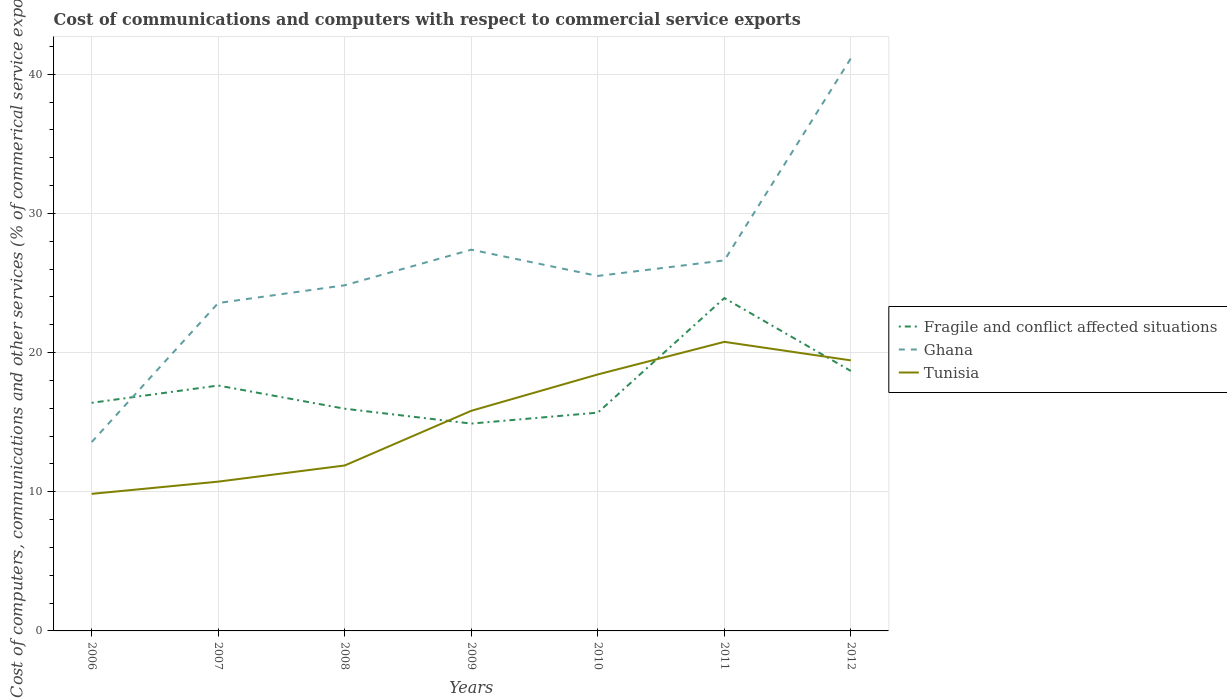Does the line corresponding to Ghana intersect with the line corresponding to Fragile and conflict affected situations?
Your response must be concise. Yes. Across all years, what is the maximum cost of communications and computers in Tunisia?
Your response must be concise. 9.85. What is the total cost of communications and computers in Ghana in the graph?
Provide a succinct answer. -13.75. What is the difference between the highest and the second highest cost of communications and computers in Ghana?
Ensure brevity in your answer.  27.57. How many lines are there?
Your response must be concise. 3. How many years are there in the graph?
Ensure brevity in your answer.  7. Are the values on the major ticks of Y-axis written in scientific E-notation?
Provide a succinct answer. No. Does the graph contain grids?
Give a very brief answer. Yes. Where does the legend appear in the graph?
Your response must be concise. Center right. How many legend labels are there?
Keep it short and to the point. 3. What is the title of the graph?
Offer a very short reply. Cost of communications and computers with respect to commercial service exports. Does "Hungary" appear as one of the legend labels in the graph?
Your answer should be compact. No. What is the label or title of the Y-axis?
Ensure brevity in your answer.  Cost of computers, communications and other services (% of commerical service exports). What is the Cost of computers, communications and other services (% of commerical service exports) in Fragile and conflict affected situations in 2006?
Make the answer very short. 16.39. What is the Cost of computers, communications and other services (% of commerical service exports) of Ghana in 2006?
Your answer should be very brief. 13.57. What is the Cost of computers, communications and other services (% of commerical service exports) in Tunisia in 2006?
Keep it short and to the point. 9.85. What is the Cost of computers, communications and other services (% of commerical service exports) of Fragile and conflict affected situations in 2007?
Make the answer very short. 17.63. What is the Cost of computers, communications and other services (% of commerical service exports) of Ghana in 2007?
Give a very brief answer. 23.56. What is the Cost of computers, communications and other services (% of commerical service exports) in Tunisia in 2007?
Ensure brevity in your answer.  10.73. What is the Cost of computers, communications and other services (% of commerical service exports) of Fragile and conflict affected situations in 2008?
Your answer should be very brief. 15.97. What is the Cost of computers, communications and other services (% of commerical service exports) in Ghana in 2008?
Provide a short and direct response. 24.84. What is the Cost of computers, communications and other services (% of commerical service exports) in Tunisia in 2008?
Your response must be concise. 11.89. What is the Cost of computers, communications and other services (% of commerical service exports) of Fragile and conflict affected situations in 2009?
Your response must be concise. 14.9. What is the Cost of computers, communications and other services (% of commerical service exports) in Ghana in 2009?
Keep it short and to the point. 27.39. What is the Cost of computers, communications and other services (% of commerical service exports) of Tunisia in 2009?
Make the answer very short. 15.82. What is the Cost of computers, communications and other services (% of commerical service exports) of Fragile and conflict affected situations in 2010?
Provide a succinct answer. 15.68. What is the Cost of computers, communications and other services (% of commerical service exports) in Ghana in 2010?
Keep it short and to the point. 25.51. What is the Cost of computers, communications and other services (% of commerical service exports) in Tunisia in 2010?
Provide a short and direct response. 18.43. What is the Cost of computers, communications and other services (% of commerical service exports) of Fragile and conflict affected situations in 2011?
Your response must be concise. 23.92. What is the Cost of computers, communications and other services (% of commerical service exports) in Ghana in 2011?
Keep it short and to the point. 26.62. What is the Cost of computers, communications and other services (% of commerical service exports) in Tunisia in 2011?
Your response must be concise. 20.77. What is the Cost of computers, communications and other services (% of commerical service exports) of Fragile and conflict affected situations in 2012?
Your answer should be compact. 18.68. What is the Cost of computers, communications and other services (% of commerical service exports) in Ghana in 2012?
Keep it short and to the point. 41.14. What is the Cost of computers, communications and other services (% of commerical service exports) of Tunisia in 2012?
Provide a succinct answer. 19.44. Across all years, what is the maximum Cost of computers, communications and other services (% of commerical service exports) in Fragile and conflict affected situations?
Provide a succinct answer. 23.92. Across all years, what is the maximum Cost of computers, communications and other services (% of commerical service exports) in Ghana?
Give a very brief answer. 41.14. Across all years, what is the maximum Cost of computers, communications and other services (% of commerical service exports) of Tunisia?
Provide a succinct answer. 20.77. Across all years, what is the minimum Cost of computers, communications and other services (% of commerical service exports) in Fragile and conflict affected situations?
Offer a very short reply. 14.9. Across all years, what is the minimum Cost of computers, communications and other services (% of commerical service exports) in Ghana?
Give a very brief answer. 13.57. Across all years, what is the minimum Cost of computers, communications and other services (% of commerical service exports) in Tunisia?
Offer a terse response. 9.85. What is the total Cost of computers, communications and other services (% of commerical service exports) in Fragile and conflict affected situations in the graph?
Make the answer very short. 123.17. What is the total Cost of computers, communications and other services (% of commerical service exports) of Ghana in the graph?
Ensure brevity in your answer.  182.63. What is the total Cost of computers, communications and other services (% of commerical service exports) of Tunisia in the graph?
Make the answer very short. 106.92. What is the difference between the Cost of computers, communications and other services (% of commerical service exports) in Fragile and conflict affected situations in 2006 and that in 2007?
Provide a short and direct response. -1.24. What is the difference between the Cost of computers, communications and other services (% of commerical service exports) of Ghana in 2006 and that in 2007?
Your answer should be compact. -9.99. What is the difference between the Cost of computers, communications and other services (% of commerical service exports) of Tunisia in 2006 and that in 2007?
Offer a terse response. -0.88. What is the difference between the Cost of computers, communications and other services (% of commerical service exports) of Fragile and conflict affected situations in 2006 and that in 2008?
Your answer should be compact. 0.42. What is the difference between the Cost of computers, communications and other services (% of commerical service exports) of Ghana in 2006 and that in 2008?
Give a very brief answer. -11.27. What is the difference between the Cost of computers, communications and other services (% of commerical service exports) in Tunisia in 2006 and that in 2008?
Offer a terse response. -2.04. What is the difference between the Cost of computers, communications and other services (% of commerical service exports) in Fragile and conflict affected situations in 2006 and that in 2009?
Give a very brief answer. 1.49. What is the difference between the Cost of computers, communications and other services (% of commerical service exports) in Ghana in 2006 and that in 2009?
Offer a very short reply. -13.83. What is the difference between the Cost of computers, communications and other services (% of commerical service exports) of Tunisia in 2006 and that in 2009?
Provide a succinct answer. -5.97. What is the difference between the Cost of computers, communications and other services (% of commerical service exports) of Fragile and conflict affected situations in 2006 and that in 2010?
Make the answer very short. 0.71. What is the difference between the Cost of computers, communications and other services (% of commerical service exports) in Ghana in 2006 and that in 2010?
Keep it short and to the point. -11.94. What is the difference between the Cost of computers, communications and other services (% of commerical service exports) of Tunisia in 2006 and that in 2010?
Offer a very short reply. -8.58. What is the difference between the Cost of computers, communications and other services (% of commerical service exports) of Fragile and conflict affected situations in 2006 and that in 2011?
Provide a short and direct response. -7.53. What is the difference between the Cost of computers, communications and other services (% of commerical service exports) of Ghana in 2006 and that in 2011?
Offer a very short reply. -13.06. What is the difference between the Cost of computers, communications and other services (% of commerical service exports) in Tunisia in 2006 and that in 2011?
Your answer should be compact. -10.92. What is the difference between the Cost of computers, communications and other services (% of commerical service exports) of Fragile and conflict affected situations in 2006 and that in 2012?
Keep it short and to the point. -2.29. What is the difference between the Cost of computers, communications and other services (% of commerical service exports) of Ghana in 2006 and that in 2012?
Provide a short and direct response. -27.57. What is the difference between the Cost of computers, communications and other services (% of commerical service exports) in Tunisia in 2006 and that in 2012?
Ensure brevity in your answer.  -9.59. What is the difference between the Cost of computers, communications and other services (% of commerical service exports) of Fragile and conflict affected situations in 2007 and that in 2008?
Provide a short and direct response. 1.67. What is the difference between the Cost of computers, communications and other services (% of commerical service exports) in Ghana in 2007 and that in 2008?
Provide a succinct answer. -1.28. What is the difference between the Cost of computers, communications and other services (% of commerical service exports) of Tunisia in 2007 and that in 2008?
Give a very brief answer. -1.16. What is the difference between the Cost of computers, communications and other services (% of commerical service exports) of Fragile and conflict affected situations in 2007 and that in 2009?
Offer a terse response. 2.73. What is the difference between the Cost of computers, communications and other services (% of commerical service exports) in Ghana in 2007 and that in 2009?
Ensure brevity in your answer.  -3.83. What is the difference between the Cost of computers, communications and other services (% of commerical service exports) in Tunisia in 2007 and that in 2009?
Your response must be concise. -5.09. What is the difference between the Cost of computers, communications and other services (% of commerical service exports) in Fragile and conflict affected situations in 2007 and that in 2010?
Provide a short and direct response. 1.95. What is the difference between the Cost of computers, communications and other services (% of commerical service exports) in Ghana in 2007 and that in 2010?
Keep it short and to the point. -1.95. What is the difference between the Cost of computers, communications and other services (% of commerical service exports) of Tunisia in 2007 and that in 2010?
Provide a succinct answer. -7.7. What is the difference between the Cost of computers, communications and other services (% of commerical service exports) in Fragile and conflict affected situations in 2007 and that in 2011?
Your answer should be very brief. -6.28. What is the difference between the Cost of computers, communications and other services (% of commerical service exports) of Ghana in 2007 and that in 2011?
Make the answer very short. -3.06. What is the difference between the Cost of computers, communications and other services (% of commerical service exports) of Tunisia in 2007 and that in 2011?
Keep it short and to the point. -10.04. What is the difference between the Cost of computers, communications and other services (% of commerical service exports) in Fragile and conflict affected situations in 2007 and that in 2012?
Your answer should be very brief. -1.05. What is the difference between the Cost of computers, communications and other services (% of commerical service exports) of Ghana in 2007 and that in 2012?
Offer a terse response. -17.58. What is the difference between the Cost of computers, communications and other services (% of commerical service exports) in Tunisia in 2007 and that in 2012?
Ensure brevity in your answer.  -8.71. What is the difference between the Cost of computers, communications and other services (% of commerical service exports) in Fragile and conflict affected situations in 2008 and that in 2009?
Give a very brief answer. 1.07. What is the difference between the Cost of computers, communications and other services (% of commerical service exports) of Ghana in 2008 and that in 2009?
Provide a short and direct response. -2.56. What is the difference between the Cost of computers, communications and other services (% of commerical service exports) in Tunisia in 2008 and that in 2009?
Provide a short and direct response. -3.93. What is the difference between the Cost of computers, communications and other services (% of commerical service exports) of Fragile and conflict affected situations in 2008 and that in 2010?
Your answer should be very brief. 0.28. What is the difference between the Cost of computers, communications and other services (% of commerical service exports) of Ghana in 2008 and that in 2010?
Make the answer very short. -0.67. What is the difference between the Cost of computers, communications and other services (% of commerical service exports) of Tunisia in 2008 and that in 2010?
Provide a succinct answer. -6.54. What is the difference between the Cost of computers, communications and other services (% of commerical service exports) of Fragile and conflict affected situations in 2008 and that in 2011?
Your answer should be compact. -7.95. What is the difference between the Cost of computers, communications and other services (% of commerical service exports) in Ghana in 2008 and that in 2011?
Keep it short and to the point. -1.79. What is the difference between the Cost of computers, communications and other services (% of commerical service exports) of Tunisia in 2008 and that in 2011?
Your answer should be very brief. -8.88. What is the difference between the Cost of computers, communications and other services (% of commerical service exports) in Fragile and conflict affected situations in 2008 and that in 2012?
Your answer should be very brief. -2.71. What is the difference between the Cost of computers, communications and other services (% of commerical service exports) in Ghana in 2008 and that in 2012?
Offer a very short reply. -16.3. What is the difference between the Cost of computers, communications and other services (% of commerical service exports) of Tunisia in 2008 and that in 2012?
Your answer should be compact. -7.55. What is the difference between the Cost of computers, communications and other services (% of commerical service exports) of Fragile and conflict affected situations in 2009 and that in 2010?
Your response must be concise. -0.79. What is the difference between the Cost of computers, communications and other services (% of commerical service exports) of Ghana in 2009 and that in 2010?
Your response must be concise. 1.89. What is the difference between the Cost of computers, communications and other services (% of commerical service exports) of Tunisia in 2009 and that in 2010?
Provide a succinct answer. -2.61. What is the difference between the Cost of computers, communications and other services (% of commerical service exports) of Fragile and conflict affected situations in 2009 and that in 2011?
Make the answer very short. -9.02. What is the difference between the Cost of computers, communications and other services (% of commerical service exports) in Ghana in 2009 and that in 2011?
Ensure brevity in your answer.  0.77. What is the difference between the Cost of computers, communications and other services (% of commerical service exports) in Tunisia in 2009 and that in 2011?
Offer a terse response. -4.95. What is the difference between the Cost of computers, communications and other services (% of commerical service exports) in Fragile and conflict affected situations in 2009 and that in 2012?
Provide a succinct answer. -3.78. What is the difference between the Cost of computers, communications and other services (% of commerical service exports) of Ghana in 2009 and that in 2012?
Your response must be concise. -13.75. What is the difference between the Cost of computers, communications and other services (% of commerical service exports) in Tunisia in 2009 and that in 2012?
Your answer should be very brief. -3.62. What is the difference between the Cost of computers, communications and other services (% of commerical service exports) of Fragile and conflict affected situations in 2010 and that in 2011?
Your response must be concise. -8.23. What is the difference between the Cost of computers, communications and other services (% of commerical service exports) in Ghana in 2010 and that in 2011?
Offer a very short reply. -1.12. What is the difference between the Cost of computers, communications and other services (% of commerical service exports) of Tunisia in 2010 and that in 2011?
Your answer should be compact. -2.34. What is the difference between the Cost of computers, communications and other services (% of commerical service exports) of Fragile and conflict affected situations in 2010 and that in 2012?
Your answer should be compact. -3. What is the difference between the Cost of computers, communications and other services (% of commerical service exports) of Ghana in 2010 and that in 2012?
Offer a very short reply. -15.64. What is the difference between the Cost of computers, communications and other services (% of commerical service exports) in Tunisia in 2010 and that in 2012?
Offer a very short reply. -1.01. What is the difference between the Cost of computers, communications and other services (% of commerical service exports) in Fragile and conflict affected situations in 2011 and that in 2012?
Your response must be concise. 5.24. What is the difference between the Cost of computers, communications and other services (% of commerical service exports) in Ghana in 2011 and that in 2012?
Offer a terse response. -14.52. What is the difference between the Cost of computers, communications and other services (% of commerical service exports) of Tunisia in 2011 and that in 2012?
Provide a succinct answer. 1.33. What is the difference between the Cost of computers, communications and other services (% of commerical service exports) in Fragile and conflict affected situations in 2006 and the Cost of computers, communications and other services (% of commerical service exports) in Ghana in 2007?
Your response must be concise. -7.17. What is the difference between the Cost of computers, communications and other services (% of commerical service exports) in Fragile and conflict affected situations in 2006 and the Cost of computers, communications and other services (% of commerical service exports) in Tunisia in 2007?
Provide a succinct answer. 5.66. What is the difference between the Cost of computers, communications and other services (% of commerical service exports) of Ghana in 2006 and the Cost of computers, communications and other services (% of commerical service exports) of Tunisia in 2007?
Provide a succinct answer. 2.84. What is the difference between the Cost of computers, communications and other services (% of commerical service exports) in Fragile and conflict affected situations in 2006 and the Cost of computers, communications and other services (% of commerical service exports) in Ghana in 2008?
Give a very brief answer. -8.45. What is the difference between the Cost of computers, communications and other services (% of commerical service exports) in Fragile and conflict affected situations in 2006 and the Cost of computers, communications and other services (% of commerical service exports) in Tunisia in 2008?
Your answer should be very brief. 4.5. What is the difference between the Cost of computers, communications and other services (% of commerical service exports) of Ghana in 2006 and the Cost of computers, communications and other services (% of commerical service exports) of Tunisia in 2008?
Give a very brief answer. 1.68. What is the difference between the Cost of computers, communications and other services (% of commerical service exports) in Fragile and conflict affected situations in 2006 and the Cost of computers, communications and other services (% of commerical service exports) in Ghana in 2009?
Provide a short and direct response. -11. What is the difference between the Cost of computers, communications and other services (% of commerical service exports) of Fragile and conflict affected situations in 2006 and the Cost of computers, communications and other services (% of commerical service exports) of Tunisia in 2009?
Your response must be concise. 0.57. What is the difference between the Cost of computers, communications and other services (% of commerical service exports) of Ghana in 2006 and the Cost of computers, communications and other services (% of commerical service exports) of Tunisia in 2009?
Offer a terse response. -2.25. What is the difference between the Cost of computers, communications and other services (% of commerical service exports) in Fragile and conflict affected situations in 2006 and the Cost of computers, communications and other services (% of commerical service exports) in Ghana in 2010?
Keep it short and to the point. -9.12. What is the difference between the Cost of computers, communications and other services (% of commerical service exports) in Fragile and conflict affected situations in 2006 and the Cost of computers, communications and other services (% of commerical service exports) in Tunisia in 2010?
Provide a succinct answer. -2.04. What is the difference between the Cost of computers, communications and other services (% of commerical service exports) of Ghana in 2006 and the Cost of computers, communications and other services (% of commerical service exports) of Tunisia in 2010?
Offer a very short reply. -4.86. What is the difference between the Cost of computers, communications and other services (% of commerical service exports) of Fragile and conflict affected situations in 2006 and the Cost of computers, communications and other services (% of commerical service exports) of Ghana in 2011?
Your answer should be compact. -10.23. What is the difference between the Cost of computers, communications and other services (% of commerical service exports) of Fragile and conflict affected situations in 2006 and the Cost of computers, communications and other services (% of commerical service exports) of Tunisia in 2011?
Provide a succinct answer. -4.38. What is the difference between the Cost of computers, communications and other services (% of commerical service exports) in Ghana in 2006 and the Cost of computers, communications and other services (% of commerical service exports) in Tunisia in 2011?
Give a very brief answer. -7.2. What is the difference between the Cost of computers, communications and other services (% of commerical service exports) in Fragile and conflict affected situations in 2006 and the Cost of computers, communications and other services (% of commerical service exports) in Ghana in 2012?
Your answer should be compact. -24.75. What is the difference between the Cost of computers, communications and other services (% of commerical service exports) in Fragile and conflict affected situations in 2006 and the Cost of computers, communications and other services (% of commerical service exports) in Tunisia in 2012?
Ensure brevity in your answer.  -3.05. What is the difference between the Cost of computers, communications and other services (% of commerical service exports) of Ghana in 2006 and the Cost of computers, communications and other services (% of commerical service exports) of Tunisia in 2012?
Make the answer very short. -5.87. What is the difference between the Cost of computers, communications and other services (% of commerical service exports) in Fragile and conflict affected situations in 2007 and the Cost of computers, communications and other services (% of commerical service exports) in Ghana in 2008?
Your response must be concise. -7.2. What is the difference between the Cost of computers, communications and other services (% of commerical service exports) of Fragile and conflict affected situations in 2007 and the Cost of computers, communications and other services (% of commerical service exports) of Tunisia in 2008?
Ensure brevity in your answer.  5.74. What is the difference between the Cost of computers, communications and other services (% of commerical service exports) in Ghana in 2007 and the Cost of computers, communications and other services (% of commerical service exports) in Tunisia in 2008?
Provide a succinct answer. 11.67. What is the difference between the Cost of computers, communications and other services (% of commerical service exports) of Fragile and conflict affected situations in 2007 and the Cost of computers, communications and other services (% of commerical service exports) of Ghana in 2009?
Your response must be concise. -9.76. What is the difference between the Cost of computers, communications and other services (% of commerical service exports) of Fragile and conflict affected situations in 2007 and the Cost of computers, communications and other services (% of commerical service exports) of Tunisia in 2009?
Your answer should be very brief. 1.82. What is the difference between the Cost of computers, communications and other services (% of commerical service exports) of Ghana in 2007 and the Cost of computers, communications and other services (% of commerical service exports) of Tunisia in 2009?
Ensure brevity in your answer.  7.74. What is the difference between the Cost of computers, communications and other services (% of commerical service exports) of Fragile and conflict affected situations in 2007 and the Cost of computers, communications and other services (% of commerical service exports) of Ghana in 2010?
Provide a short and direct response. -7.87. What is the difference between the Cost of computers, communications and other services (% of commerical service exports) of Fragile and conflict affected situations in 2007 and the Cost of computers, communications and other services (% of commerical service exports) of Tunisia in 2010?
Make the answer very short. -0.8. What is the difference between the Cost of computers, communications and other services (% of commerical service exports) of Ghana in 2007 and the Cost of computers, communications and other services (% of commerical service exports) of Tunisia in 2010?
Your answer should be very brief. 5.13. What is the difference between the Cost of computers, communications and other services (% of commerical service exports) of Fragile and conflict affected situations in 2007 and the Cost of computers, communications and other services (% of commerical service exports) of Ghana in 2011?
Offer a very short reply. -8.99. What is the difference between the Cost of computers, communications and other services (% of commerical service exports) in Fragile and conflict affected situations in 2007 and the Cost of computers, communications and other services (% of commerical service exports) in Tunisia in 2011?
Ensure brevity in your answer.  -3.14. What is the difference between the Cost of computers, communications and other services (% of commerical service exports) in Ghana in 2007 and the Cost of computers, communications and other services (% of commerical service exports) in Tunisia in 2011?
Keep it short and to the point. 2.79. What is the difference between the Cost of computers, communications and other services (% of commerical service exports) in Fragile and conflict affected situations in 2007 and the Cost of computers, communications and other services (% of commerical service exports) in Ghana in 2012?
Give a very brief answer. -23.51. What is the difference between the Cost of computers, communications and other services (% of commerical service exports) of Fragile and conflict affected situations in 2007 and the Cost of computers, communications and other services (% of commerical service exports) of Tunisia in 2012?
Offer a very short reply. -1.81. What is the difference between the Cost of computers, communications and other services (% of commerical service exports) in Ghana in 2007 and the Cost of computers, communications and other services (% of commerical service exports) in Tunisia in 2012?
Your answer should be very brief. 4.12. What is the difference between the Cost of computers, communications and other services (% of commerical service exports) in Fragile and conflict affected situations in 2008 and the Cost of computers, communications and other services (% of commerical service exports) in Ghana in 2009?
Provide a succinct answer. -11.43. What is the difference between the Cost of computers, communications and other services (% of commerical service exports) of Fragile and conflict affected situations in 2008 and the Cost of computers, communications and other services (% of commerical service exports) of Tunisia in 2009?
Make the answer very short. 0.15. What is the difference between the Cost of computers, communications and other services (% of commerical service exports) of Ghana in 2008 and the Cost of computers, communications and other services (% of commerical service exports) of Tunisia in 2009?
Provide a short and direct response. 9.02. What is the difference between the Cost of computers, communications and other services (% of commerical service exports) in Fragile and conflict affected situations in 2008 and the Cost of computers, communications and other services (% of commerical service exports) in Ghana in 2010?
Your answer should be very brief. -9.54. What is the difference between the Cost of computers, communications and other services (% of commerical service exports) in Fragile and conflict affected situations in 2008 and the Cost of computers, communications and other services (% of commerical service exports) in Tunisia in 2010?
Keep it short and to the point. -2.46. What is the difference between the Cost of computers, communications and other services (% of commerical service exports) in Ghana in 2008 and the Cost of computers, communications and other services (% of commerical service exports) in Tunisia in 2010?
Provide a succinct answer. 6.41. What is the difference between the Cost of computers, communications and other services (% of commerical service exports) of Fragile and conflict affected situations in 2008 and the Cost of computers, communications and other services (% of commerical service exports) of Ghana in 2011?
Keep it short and to the point. -10.66. What is the difference between the Cost of computers, communications and other services (% of commerical service exports) of Fragile and conflict affected situations in 2008 and the Cost of computers, communications and other services (% of commerical service exports) of Tunisia in 2011?
Give a very brief answer. -4.8. What is the difference between the Cost of computers, communications and other services (% of commerical service exports) of Ghana in 2008 and the Cost of computers, communications and other services (% of commerical service exports) of Tunisia in 2011?
Your response must be concise. 4.07. What is the difference between the Cost of computers, communications and other services (% of commerical service exports) of Fragile and conflict affected situations in 2008 and the Cost of computers, communications and other services (% of commerical service exports) of Ghana in 2012?
Provide a succinct answer. -25.18. What is the difference between the Cost of computers, communications and other services (% of commerical service exports) in Fragile and conflict affected situations in 2008 and the Cost of computers, communications and other services (% of commerical service exports) in Tunisia in 2012?
Keep it short and to the point. -3.47. What is the difference between the Cost of computers, communications and other services (% of commerical service exports) of Ghana in 2008 and the Cost of computers, communications and other services (% of commerical service exports) of Tunisia in 2012?
Offer a terse response. 5.4. What is the difference between the Cost of computers, communications and other services (% of commerical service exports) of Fragile and conflict affected situations in 2009 and the Cost of computers, communications and other services (% of commerical service exports) of Ghana in 2010?
Your response must be concise. -10.61. What is the difference between the Cost of computers, communications and other services (% of commerical service exports) of Fragile and conflict affected situations in 2009 and the Cost of computers, communications and other services (% of commerical service exports) of Tunisia in 2010?
Your response must be concise. -3.53. What is the difference between the Cost of computers, communications and other services (% of commerical service exports) in Ghana in 2009 and the Cost of computers, communications and other services (% of commerical service exports) in Tunisia in 2010?
Offer a terse response. 8.96. What is the difference between the Cost of computers, communications and other services (% of commerical service exports) of Fragile and conflict affected situations in 2009 and the Cost of computers, communications and other services (% of commerical service exports) of Ghana in 2011?
Your answer should be very brief. -11.73. What is the difference between the Cost of computers, communications and other services (% of commerical service exports) of Fragile and conflict affected situations in 2009 and the Cost of computers, communications and other services (% of commerical service exports) of Tunisia in 2011?
Provide a succinct answer. -5.87. What is the difference between the Cost of computers, communications and other services (% of commerical service exports) in Ghana in 2009 and the Cost of computers, communications and other services (% of commerical service exports) in Tunisia in 2011?
Ensure brevity in your answer.  6.62. What is the difference between the Cost of computers, communications and other services (% of commerical service exports) in Fragile and conflict affected situations in 2009 and the Cost of computers, communications and other services (% of commerical service exports) in Ghana in 2012?
Keep it short and to the point. -26.24. What is the difference between the Cost of computers, communications and other services (% of commerical service exports) of Fragile and conflict affected situations in 2009 and the Cost of computers, communications and other services (% of commerical service exports) of Tunisia in 2012?
Offer a terse response. -4.54. What is the difference between the Cost of computers, communications and other services (% of commerical service exports) of Ghana in 2009 and the Cost of computers, communications and other services (% of commerical service exports) of Tunisia in 2012?
Give a very brief answer. 7.95. What is the difference between the Cost of computers, communications and other services (% of commerical service exports) in Fragile and conflict affected situations in 2010 and the Cost of computers, communications and other services (% of commerical service exports) in Ghana in 2011?
Your answer should be compact. -10.94. What is the difference between the Cost of computers, communications and other services (% of commerical service exports) of Fragile and conflict affected situations in 2010 and the Cost of computers, communications and other services (% of commerical service exports) of Tunisia in 2011?
Your answer should be very brief. -5.09. What is the difference between the Cost of computers, communications and other services (% of commerical service exports) of Ghana in 2010 and the Cost of computers, communications and other services (% of commerical service exports) of Tunisia in 2011?
Your answer should be compact. 4.74. What is the difference between the Cost of computers, communications and other services (% of commerical service exports) in Fragile and conflict affected situations in 2010 and the Cost of computers, communications and other services (% of commerical service exports) in Ghana in 2012?
Make the answer very short. -25.46. What is the difference between the Cost of computers, communications and other services (% of commerical service exports) in Fragile and conflict affected situations in 2010 and the Cost of computers, communications and other services (% of commerical service exports) in Tunisia in 2012?
Give a very brief answer. -3.76. What is the difference between the Cost of computers, communications and other services (% of commerical service exports) of Ghana in 2010 and the Cost of computers, communications and other services (% of commerical service exports) of Tunisia in 2012?
Offer a terse response. 6.07. What is the difference between the Cost of computers, communications and other services (% of commerical service exports) in Fragile and conflict affected situations in 2011 and the Cost of computers, communications and other services (% of commerical service exports) in Ghana in 2012?
Keep it short and to the point. -17.23. What is the difference between the Cost of computers, communications and other services (% of commerical service exports) of Fragile and conflict affected situations in 2011 and the Cost of computers, communications and other services (% of commerical service exports) of Tunisia in 2012?
Offer a terse response. 4.48. What is the difference between the Cost of computers, communications and other services (% of commerical service exports) of Ghana in 2011 and the Cost of computers, communications and other services (% of commerical service exports) of Tunisia in 2012?
Give a very brief answer. 7.18. What is the average Cost of computers, communications and other services (% of commerical service exports) of Fragile and conflict affected situations per year?
Give a very brief answer. 17.6. What is the average Cost of computers, communications and other services (% of commerical service exports) in Ghana per year?
Give a very brief answer. 26.09. What is the average Cost of computers, communications and other services (% of commerical service exports) of Tunisia per year?
Ensure brevity in your answer.  15.27. In the year 2006, what is the difference between the Cost of computers, communications and other services (% of commerical service exports) of Fragile and conflict affected situations and Cost of computers, communications and other services (% of commerical service exports) of Ghana?
Provide a short and direct response. 2.82. In the year 2006, what is the difference between the Cost of computers, communications and other services (% of commerical service exports) of Fragile and conflict affected situations and Cost of computers, communications and other services (% of commerical service exports) of Tunisia?
Provide a succinct answer. 6.54. In the year 2006, what is the difference between the Cost of computers, communications and other services (% of commerical service exports) in Ghana and Cost of computers, communications and other services (% of commerical service exports) in Tunisia?
Make the answer very short. 3.72. In the year 2007, what is the difference between the Cost of computers, communications and other services (% of commerical service exports) of Fragile and conflict affected situations and Cost of computers, communications and other services (% of commerical service exports) of Ghana?
Offer a terse response. -5.93. In the year 2007, what is the difference between the Cost of computers, communications and other services (% of commerical service exports) of Fragile and conflict affected situations and Cost of computers, communications and other services (% of commerical service exports) of Tunisia?
Provide a succinct answer. 6.91. In the year 2007, what is the difference between the Cost of computers, communications and other services (% of commerical service exports) in Ghana and Cost of computers, communications and other services (% of commerical service exports) in Tunisia?
Offer a very short reply. 12.83. In the year 2008, what is the difference between the Cost of computers, communications and other services (% of commerical service exports) in Fragile and conflict affected situations and Cost of computers, communications and other services (% of commerical service exports) in Ghana?
Provide a succinct answer. -8.87. In the year 2008, what is the difference between the Cost of computers, communications and other services (% of commerical service exports) in Fragile and conflict affected situations and Cost of computers, communications and other services (% of commerical service exports) in Tunisia?
Offer a very short reply. 4.08. In the year 2008, what is the difference between the Cost of computers, communications and other services (% of commerical service exports) in Ghana and Cost of computers, communications and other services (% of commerical service exports) in Tunisia?
Your answer should be very brief. 12.95. In the year 2009, what is the difference between the Cost of computers, communications and other services (% of commerical service exports) of Fragile and conflict affected situations and Cost of computers, communications and other services (% of commerical service exports) of Ghana?
Your response must be concise. -12.5. In the year 2009, what is the difference between the Cost of computers, communications and other services (% of commerical service exports) of Fragile and conflict affected situations and Cost of computers, communications and other services (% of commerical service exports) of Tunisia?
Your response must be concise. -0.92. In the year 2009, what is the difference between the Cost of computers, communications and other services (% of commerical service exports) in Ghana and Cost of computers, communications and other services (% of commerical service exports) in Tunisia?
Offer a very short reply. 11.58. In the year 2010, what is the difference between the Cost of computers, communications and other services (% of commerical service exports) of Fragile and conflict affected situations and Cost of computers, communications and other services (% of commerical service exports) of Ghana?
Offer a very short reply. -9.82. In the year 2010, what is the difference between the Cost of computers, communications and other services (% of commerical service exports) in Fragile and conflict affected situations and Cost of computers, communications and other services (% of commerical service exports) in Tunisia?
Your answer should be very brief. -2.75. In the year 2010, what is the difference between the Cost of computers, communications and other services (% of commerical service exports) in Ghana and Cost of computers, communications and other services (% of commerical service exports) in Tunisia?
Keep it short and to the point. 7.08. In the year 2011, what is the difference between the Cost of computers, communications and other services (% of commerical service exports) in Fragile and conflict affected situations and Cost of computers, communications and other services (% of commerical service exports) in Ghana?
Offer a terse response. -2.71. In the year 2011, what is the difference between the Cost of computers, communications and other services (% of commerical service exports) of Fragile and conflict affected situations and Cost of computers, communications and other services (% of commerical service exports) of Tunisia?
Your response must be concise. 3.15. In the year 2011, what is the difference between the Cost of computers, communications and other services (% of commerical service exports) in Ghana and Cost of computers, communications and other services (% of commerical service exports) in Tunisia?
Make the answer very short. 5.85. In the year 2012, what is the difference between the Cost of computers, communications and other services (% of commerical service exports) of Fragile and conflict affected situations and Cost of computers, communications and other services (% of commerical service exports) of Ghana?
Give a very brief answer. -22.46. In the year 2012, what is the difference between the Cost of computers, communications and other services (% of commerical service exports) of Fragile and conflict affected situations and Cost of computers, communications and other services (% of commerical service exports) of Tunisia?
Give a very brief answer. -0.76. In the year 2012, what is the difference between the Cost of computers, communications and other services (% of commerical service exports) in Ghana and Cost of computers, communications and other services (% of commerical service exports) in Tunisia?
Make the answer very short. 21.7. What is the ratio of the Cost of computers, communications and other services (% of commerical service exports) in Fragile and conflict affected situations in 2006 to that in 2007?
Your response must be concise. 0.93. What is the ratio of the Cost of computers, communications and other services (% of commerical service exports) of Ghana in 2006 to that in 2007?
Your response must be concise. 0.58. What is the ratio of the Cost of computers, communications and other services (% of commerical service exports) in Tunisia in 2006 to that in 2007?
Make the answer very short. 0.92. What is the ratio of the Cost of computers, communications and other services (% of commerical service exports) in Fragile and conflict affected situations in 2006 to that in 2008?
Keep it short and to the point. 1.03. What is the ratio of the Cost of computers, communications and other services (% of commerical service exports) in Ghana in 2006 to that in 2008?
Ensure brevity in your answer.  0.55. What is the ratio of the Cost of computers, communications and other services (% of commerical service exports) of Tunisia in 2006 to that in 2008?
Keep it short and to the point. 0.83. What is the ratio of the Cost of computers, communications and other services (% of commerical service exports) in Fragile and conflict affected situations in 2006 to that in 2009?
Your response must be concise. 1.1. What is the ratio of the Cost of computers, communications and other services (% of commerical service exports) in Ghana in 2006 to that in 2009?
Make the answer very short. 0.5. What is the ratio of the Cost of computers, communications and other services (% of commerical service exports) of Tunisia in 2006 to that in 2009?
Your response must be concise. 0.62. What is the ratio of the Cost of computers, communications and other services (% of commerical service exports) of Fragile and conflict affected situations in 2006 to that in 2010?
Your response must be concise. 1.05. What is the ratio of the Cost of computers, communications and other services (% of commerical service exports) of Ghana in 2006 to that in 2010?
Ensure brevity in your answer.  0.53. What is the ratio of the Cost of computers, communications and other services (% of commerical service exports) in Tunisia in 2006 to that in 2010?
Keep it short and to the point. 0.53. What is the ratio of the Cost of computers, communications and other services (% of commerical service exports) of Fragile and conflict affected situations in 2006 to that in 2011?
Provide a succinct answer. 0.69. What is the ratio of the Cost of computers, communications and other services (% of commerical service exports) in Ghana in 2006 to that in 2011?
Your response must be concise. 0.51. What is the ratio of the Cost of computers, communications and other services (% of commerical service exports) in Tunisia in 2006 to that in 2011?
Provide a short and direct response. 0.47. What is the ratio of the Cost of computers, communications and other services (% of commerical service exports) in Fragile and conflict affected situations in 2006 to that in 2012?
Keep it short and to the point. 0.88. What is the ratio of the Cost of computers, communications and other services (% of commerical service exports) of Ghana in 2006 to that in 2012?
Your answer should be very brief. 0.33. What is the ratio of the Cost of computers, communications and other services (% of commerical service exports) of Tunisia in 2006 to that in 2012?
Keep it short and to the point. 0.51. What is the ratio of the Cost of computers, communications and other services (% of commerical service exports) in Fragile and conflict affected situations in 2007 to that in 2008?
Ensure brevity in your answer.  1.1. What is the ratio of the Cost of computers, communications and other services (% of commerical service exports) in Ghana in 2007 to that in 2008?
Make the answer very short. 0.95. What is the ratio of the Cost of computers, communications and other services (% of commerical service exports) in Tunisia in 2007 to that in 2008?
Provide a short and direct response. 0.9. What is the ratio of the Cost of computers, communications and other services (% of commerical service exports) in Fragile and conflict affected situations in 2007 to that in 2009?
Offer a terse response. 1.18. What is the ratio of the Cost of computers, communications and other services (% of commerical service exports) in Ghana in 2007 to that in 2009?
Offer a terse response. 0.86. What is the ratio of the Cost of computers, communications and other services (% of commerical service exports) of Tunisia in 2007 to that in 2009?
Provide a short and direct response. 0.68. What is the ratio of the Cost of computers, communications and other services (% of commerical service exports) in Fragile and conflict affected situations in 2007 to that in 2010?
Make the answer very short. 1.12. What is the ratio of the Cost of computers, communications and other services (% of commerical service exports) in Ghana in 2007 to that in 2010?
Offer a terse response. 0.92. What is the ratio of the Cost of computers, communications and other services (% of commerical service exports) in Tunisia in 2007 to that in 2010?
Your answer should be very brief. 0.58. What is the ratio of the Cost of computers, communications and other services (% of commerical service exports) in Fragile and conflict affected situations in 2007 to that in 2011?
Offer a very short reply. 0.74. What is the ratio of the Cost of computers, communications and other services (% of commerical service exports) in Ghana in 2007 to that in 2011?
Offer a very short reply. 0.88. What is the ratio of the Cost of computers, communications and other services (% of commerical service exports) in Tunisia in 2007 to that in 2011?
Give a very brief answer. 0.52. What is the ratio of the Cost of computers, communications and other services (% of commerical service exports) of Fragile and conflict affected situations in 2007 to that in 2012?
Make the answer very short. 0.94. What is the ratio of the Cost of computers, communications and other services (% of commerical service exports) of Ghana in 2007 to that in 2012?
Your answer should be compact. 0.57. What is the ratio of the Cost of computers, communications and other services (% of commerical service exports) of Tunisia in 2007 to that in 2012?
Give a very brief answer. 0.55. What is the ratio of the Cost of computers, communications and other services (% of commerical service exports) of Fragile and conflict affected situations in 2008 to that in 2009?
Give a very brief answer. 1.07. What is the ratio of the Cost of computers, communications and other services (% of commerical service exports) in Ghana in 2008 to that in 2009?
Your answer should be compact. 0.91. What is the ratio of the Cost of computers, communications and other services (% of commerical service exports) in Tunisia in 2008 to that in 2009?
Your response must be concise. 0.75. What is the ratio of the Cost of computers, communications and other services (% of commerical service exports) in Ghana in 2008 to that in 2010?
Your answer should be compact. 0.97. What is the ratio of the Cost of computers, communications and other services (% of commerical service exports) of Tunisia in 2008 to that in 2010?
Your response must be concise. 0.65. What is the ratio of the Cost of computers, communications and other services (% of commerical service exports) in Fragile and conflict affected situations in 2008 to that in 2011?
Provide a succinct answer. 0.67. What is the ratio of the Cost of computers, communications and other services (% of commerical service exports) in Ghana in 2008 to that in 2011?
Offer a terse response. 0.93. What is the ratio of the Cost of computers, communications and other services (% of commerical service exports) of Tunisia in 2008 to that in 2011?
Your answer should be very brief. 0.57. What is the ratio of the Cost of computers, communications and other services (% of commerical service exports) in Fragile and conflict affected situations in 2008 to that in 2012?
Your answer should be compact. 0.85. What is the ratio of the Cost of computers, communications and other services (% of commerical service exports) of Ghana in 2008 to that in 2012?
Your answer should be very brief. 0.6. What is the ratio of the Cost of computers, communications and other services (% of commerical service exports) of Tunisia in 2008 to that in 2012?
Your answer should be compact. 0.61. What is the ratio of the Cost of computers, communications and other services (% of commerical service exports) of Fragile and conflict affected situations in 2009 to that in 2010?
Ensure brevity in your answer.  0.95. What is the ratio of the Cost of computers, communications and other services (% of commerical service exports) in Ghana in 2009 to that in 2010?
Your answer should be very brief. 1.07. What is the ratio of the Cost of computers, communications and other services (% of commerical service exports) of Tunisia in 2009 to that in 2010?
Your response must be concise. 0.86. What is the ratio of the Cost of computers, communications and other services (% of commerical service exports) of Fragile and conflict affected situations in 2009 to that in 2011?
Provide a succinct answer. 0.62. What is the ratio of the Cost of computers, communications and other services (% of commerical service exports) in Ghana in 2009 to that in 2011?
Provide a succinct answer. 1.03. What is the ratio of the Cost of computers, communications and other services (% of commerical service exports) of Tunisia in 2009 to that in 2011?
Your answer should be compact. 0.76. What is the ratio of the Cost of computers, communications and other services (% of commerical service exports) in Fragile and conflict affected situations in 2009 to that in 2012?
Give a very brief answer. 0.8. What is the ratio of the Cost of computers, communications and other services (% of commerical service exports) of Ghana in 2009 to that in 2012?
Offer a very short reply. 0.67. What is the ratio of the Cost of computers, communications and other services (% of commerical service exports) in Tunisia in 2009 to that in 2012?
Offer a very short reply. 0.81. What is the ratio of the Cost of computers, communications and other services (% of commerical service exports) of Fragile and conflict affected situations in 2010 to that in 2011?
Your response must be concise. 0.66. What is the ratio of the Cost of computers, communications and other services (% of commerical service exports) in Ghana in 2010 to that in 2011?
Give a very brief answer. 0.96. What is the ratio of the Cost of computers, communications and other services (% of commerical service exports) of Tunisia in 2010 to that in 2011?
Offer a very short reply. 0.89. What is the ratio of the Cost of computers, communications and other services (% of commerical service exports) of Fragile and conflict affected situations in 2010 to that in 2012?
Offer a terse response. 0.84. What is the ratio of the Cost of computers, communications and other services (% of commerical service exports) of Ghana in 2010 to that in 2012?
Your answer should be compact. 0.62. What is the ratio of the Cost of computers, communications and other services (% of commerical service exports) in Tunisia in 2010 to that in 2012?
Offer a very short reply. 0.95. What is the ratio of the Cost of computers, communications and other services (% of commerical service exports) of Fragile and conflict affected situations in 2011 to that in 2012?
Make the answer very short. 1.28. What is the ratio of the Cost of computers, communications and other services (% of commerical service exports) in Ghana in 2011 to that in 2012?
Make the answer very short. 0.65. What is the ratio of the Cost of computers, communications and other services (% of commerical service exports) of Tunisia in 2011 to that in 2012?
Offer a terse response. 1.07. What is the difference between the highest and the second highest Cost of computers, communications and other services (% of commerical service exports) of Fragile and conflict affected situations?
Keep it short and to the point. 5.24. What is the difference between the highest and the second highest Cost of computers, communications and other services (% of commerical service exports) of Ghana?
Provide a succinct answer. 13.75. What is the difference between the highest and the second highest Cost of computers, communications and other services (% of commerical service exports) in Tunisia?
Make the answer very short. 1.33. What is the difference between the highest and the lowest Cost of computers, communications and other services (% of commerical service exports) of Fragile and conflict affected situations?
Your answer should be compact. 9.02. What is the difference between the highest and the lowest Cost of computers, communications and other services (% of commerical service exports) of Ghana?
Provide a succinct answer. 27.57. What is the difference between the highest and the lowest Cost of computers, communications and other services (% of commerical service exports) of Tunisia?
Offer a terse response. 10.92. 